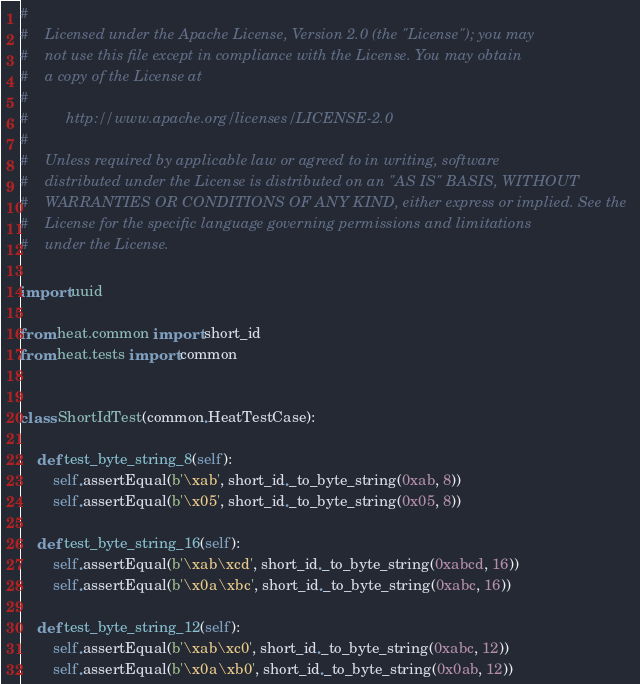Convert code to text. <code><loc_0><loc_0><loc_500><loc_500><_Python_>#
#    Licensed under the Apache License, Version 2.0 (the "License"); you may
#    not use this file except in compliance with the License. You may obtain
#    a copy of the License at
#
#         http://www.apache.org/licenses/LICENSE-2.0
#
#    Unless required by applicable law or agreed to in writing, software
#    distributed under the License is distributed on an "AS IS" BASIS, WITHOUT
#    WARRANTIES OR CONDITIONS OF ANY KIND, either express or implied. See the
#    License for the specific language governing permissions and limitations
#    under the License.

import uuid

from heat.common import short_id
from heat.tests import common


class ShortIdTest(common.HeatTestCase):

    def test_byte_string_8(self):
        self.assertEqual(b'\xab', short_id._to_byte_string(0xab, 8))
        self.assertEqual(b'\x05', short_id._to_byte_string(0x05, 8))

    def test_byte_string_16(self):
        self.assertEqual(b'\xab\xcd', short_id._to_byte_string(0xabcd, 16))
        self.assertEqual(b'\x0a\xbc', short_id._to_byte_string(0xabc, 16))

    def test_byte_string_12(self):
        self.assertEqual(b'\xab\xc0', short_id._to_byte_string(0xabc, 12))
        self.assertEqual(b'\x0a\xb0', short_id._to_byte_string(0x0ab, 12))
</code> 